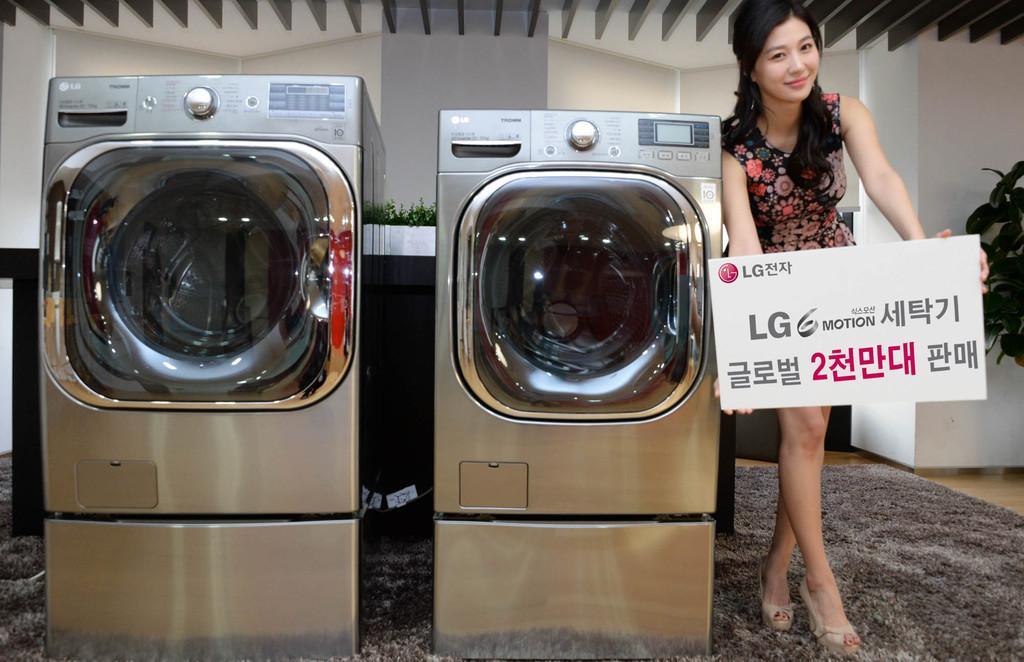Please provide a concise description of this image. In this picture, we can see a woman is standing on the carpet and holding a board and on the left side of the women there are two machines. Behind the women there are house plants and a wall. 